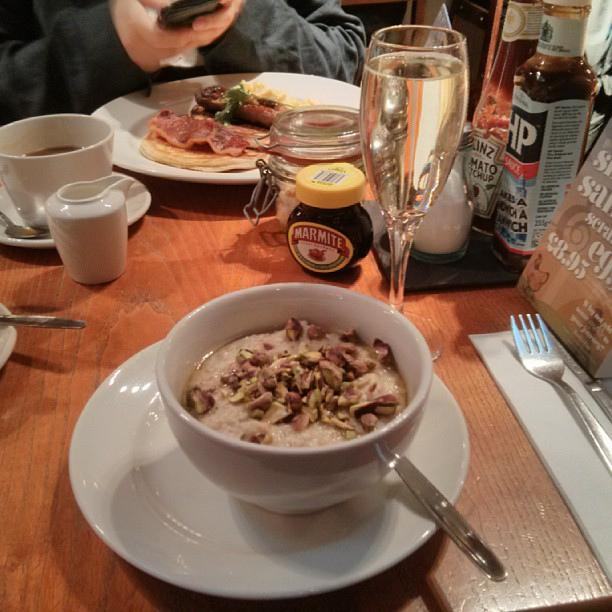The person that invented the item with the yellow lid was from what country? germany 